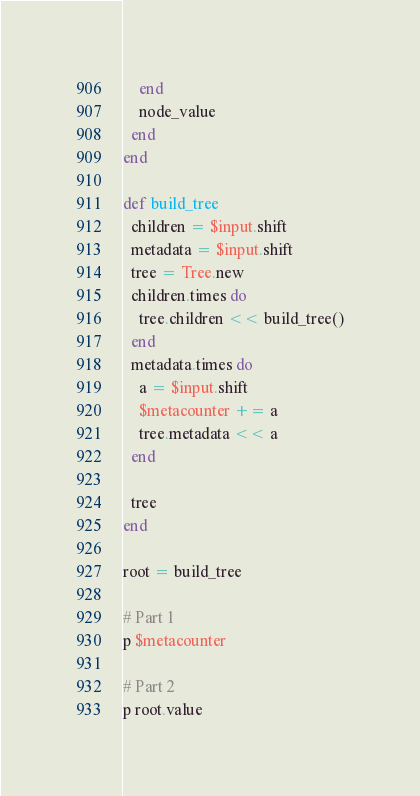Convert code to text. <code><loc_0><loc_0><loc_500><loc_500><_Ruby_>    end
    node_value
  end
end

def build_tree
  children = $input.shift
  metadata = $input.shift
  tree = Tree.new
  children.times do
    tree.children << build_tree()
  end
  metadata.times do
    a = $input.shift
    $metacounter += a
    tree.metadata << a
  end

  tree
end

root = build_tree

# Part 1
p $metacounter

# Part 2
p root.value
</code> 